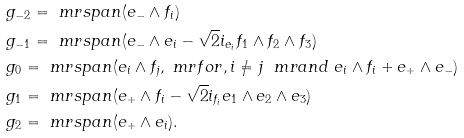<formula> <loc_0><loc_0><loc_500><loc_500>& \ g _ { - 2 } = \ m r { s p a n } ( e _ { - } \wedge f _ { i } ) \\ & \ g _ { - 1 } = \ m r { s p a n } ( e _ { - } \wedge e _ { i } - \sqrt { 2 } i _ { e _ { i } } f _ { 1 } \wedge f _ { 2 } \wedge f _ { 3 } ) \\ & \ g _ { 0 } = \ m r { s p a n } ( e _ { i } \wedge f _ { j } , \ m r { f o r } , i \not = j \ \ m r { a n d } \ e _ { i } \wedge f _ { i } + e _ { + } \wedge e _ { - } ) \\ & \ g _ { 1 } = \ m r { s p a n } ( e _ { + } \wedge f _ { i } - \sqrt { 2 } i _ { f _ { i } } e _ { 1 } \wedge e _ { 2 } \wedge e _ { 3 } ) \\ & \ g _ { 2 } = \ m r { s p a n } ( e _ { + } \wedge e _ { i } ) .</formula> 